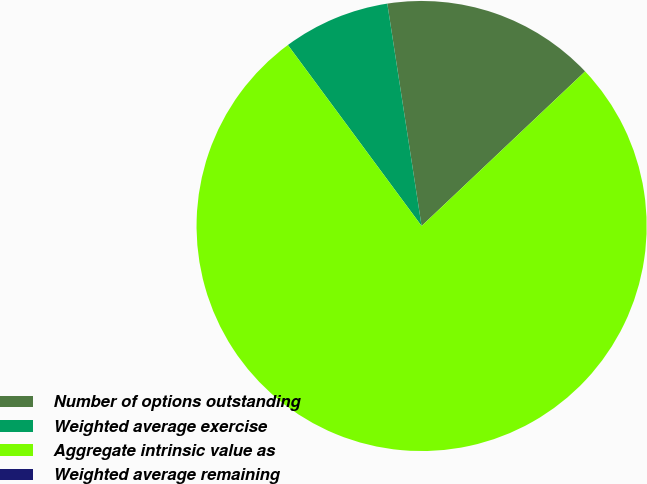<chart> <loc_0><loc_0><loc_500><loc_500><pie_chart><fcel>Number of options outstanding<fcel>Weighted average exercise<fcel>Aggregate intrinsic value as<fcel>Weighted average remaining<nl><fcel>15.38%<fcel>7.69%<fcel>76.92%<fcel>0.0%<nl></chart> 